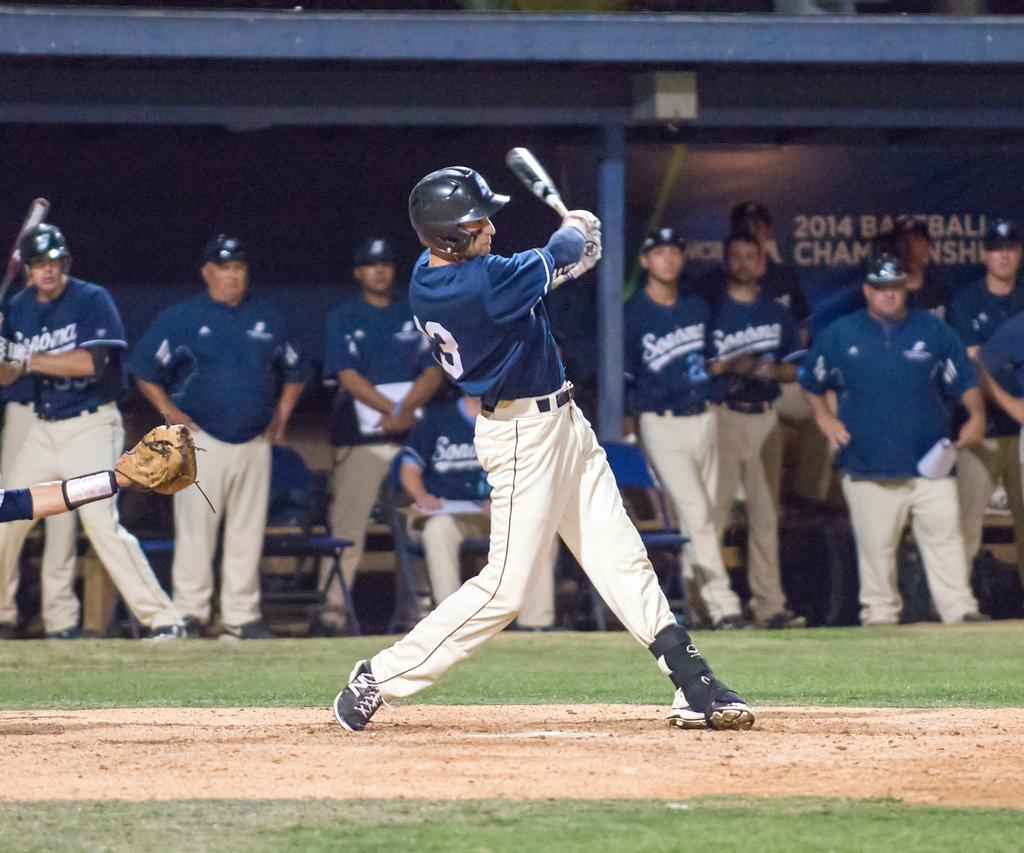<image>
Share a concise interpretation of the image provided. A batter swings as his teammates wait in a dugout with a backer than says 2014 Baseball Championships. 